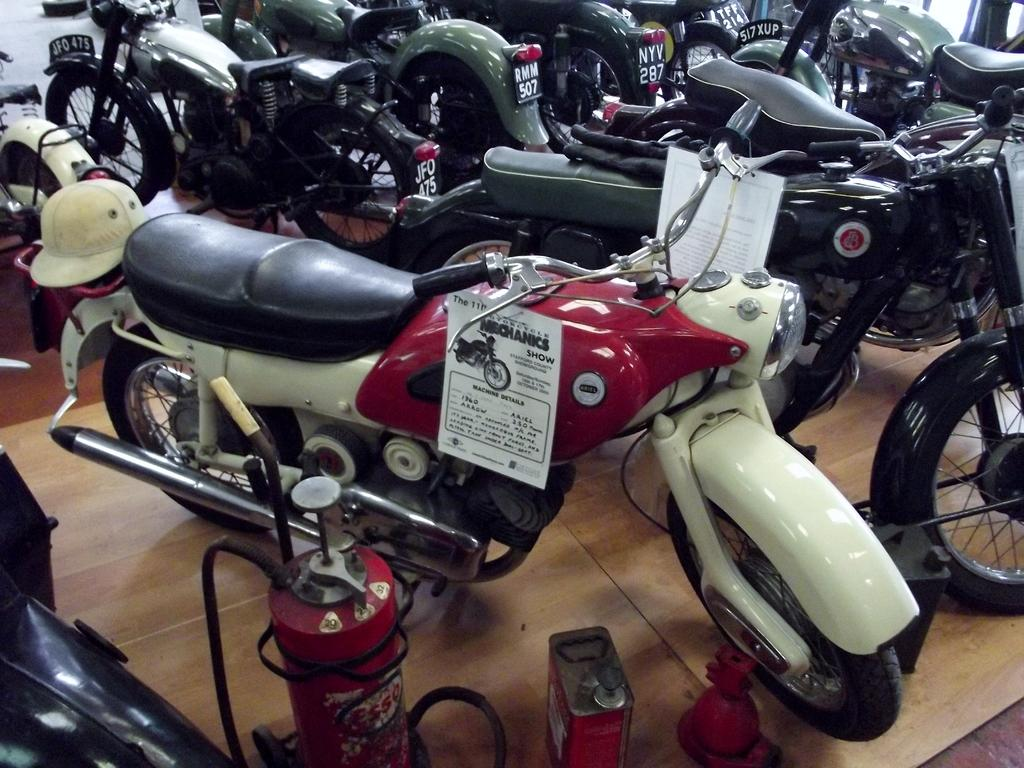What type of vehicles are in the image? There are motorcycles in the image. What other objects can be seen at the bottom of the image? There is a cylinder and a tin in the image. Can you describe the location of these objects in the image? All of these objects are located at the bottom of the image. What type of lawyer is depicted in the image? There is no lawyer present in the image; it features motorcycles, a cylinder, and a tin. How many fathers are visible in the image? There are no fathers depicted in the image. 